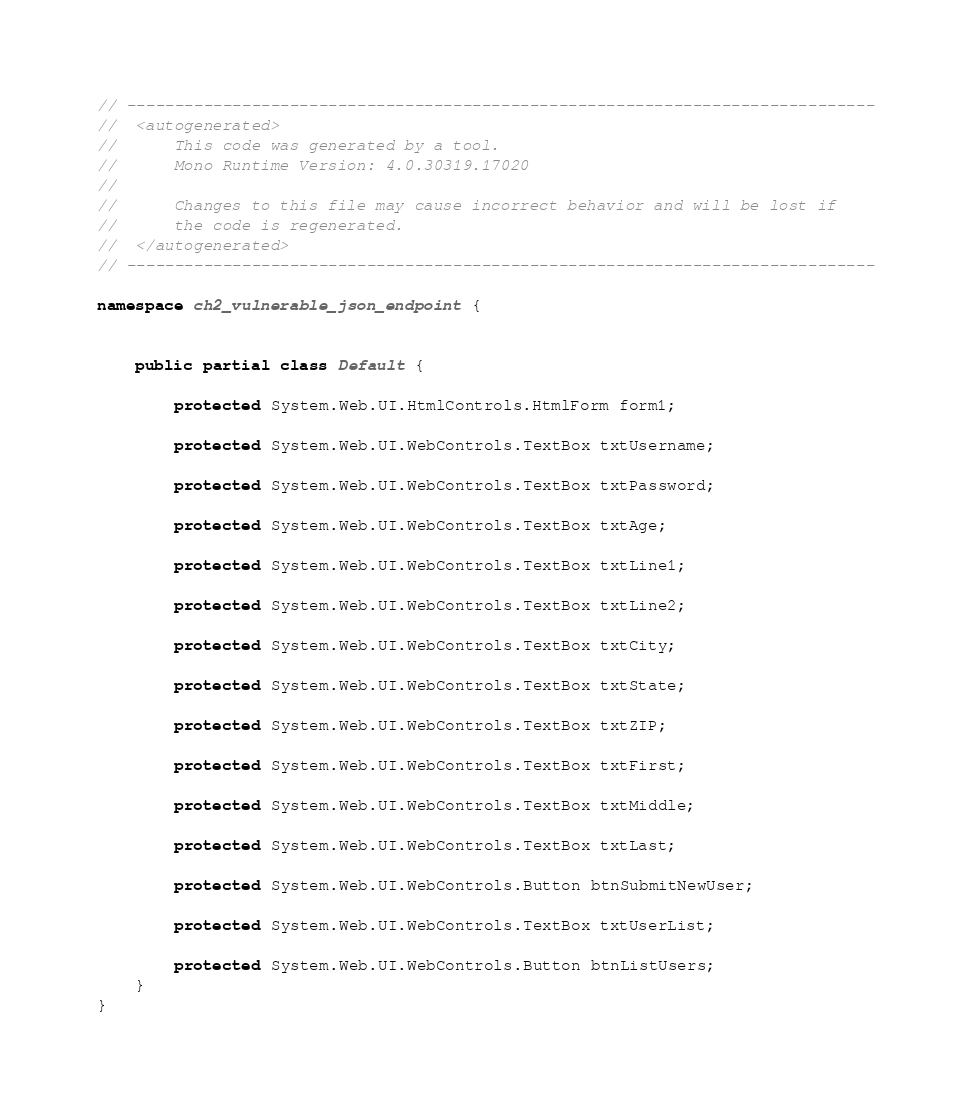Convert code to text. <code><loc_0><loc_0><loc_500><loc_500><_C#_>// ------------------------------------------------------------------------------
//  <autogenerated>
//      This code was generated by a tool.
//      Mono Runtime Version: 4.0.30319.17020
// 
//      Changes to this file may cause incorrect behavior and will be lost if 
//      the code is regenerated.
//  </autogenerated>
// ------------------------------------------------------------------------------

namespace ch2_vulnerable_json_endpoint {
	
	
	public partial class Default {
		
		protected System.Web.UI.HtmlControls.HtmlForm form1;
		
		protected System.Web.UI.WebControls.TextBox txtUsername;
		
		protected System.Web.UI.WebControls.TextBox txtPassword;
		
		protected System.Web.UI.WebControls.TextBox txtAge;
		
		protected System.Web.UI.WebControls.TextBox txtLine1;
		
		protected System.Web.UI.WebControls.TextBox txtLine2;
		
		protected System.Web.UI.WebControls.TextBox txtCity;
		
		protected System.Web.UI.WebControls.TextBox txtState;
		
		protected System.Web.UI.WebControls.TextBox txtZIP;
		
		protected System.Web.UI.WebControls.TextBox txtFirst;
		
		protected System.Web.UI.WebControls.TextBox txtMiddle;
		
		protected System.Web.UI.WebControls.TextBox txtLast;
		
		protected System.Web.UI.WebControls.Button btnSubmitNewUser;
		
		protected System.Web.UI.WebControls.TextBox txtUserList;
		
		protected System.Web.UI.WebControls.Button btnListUsers;
	}
}
</code> 